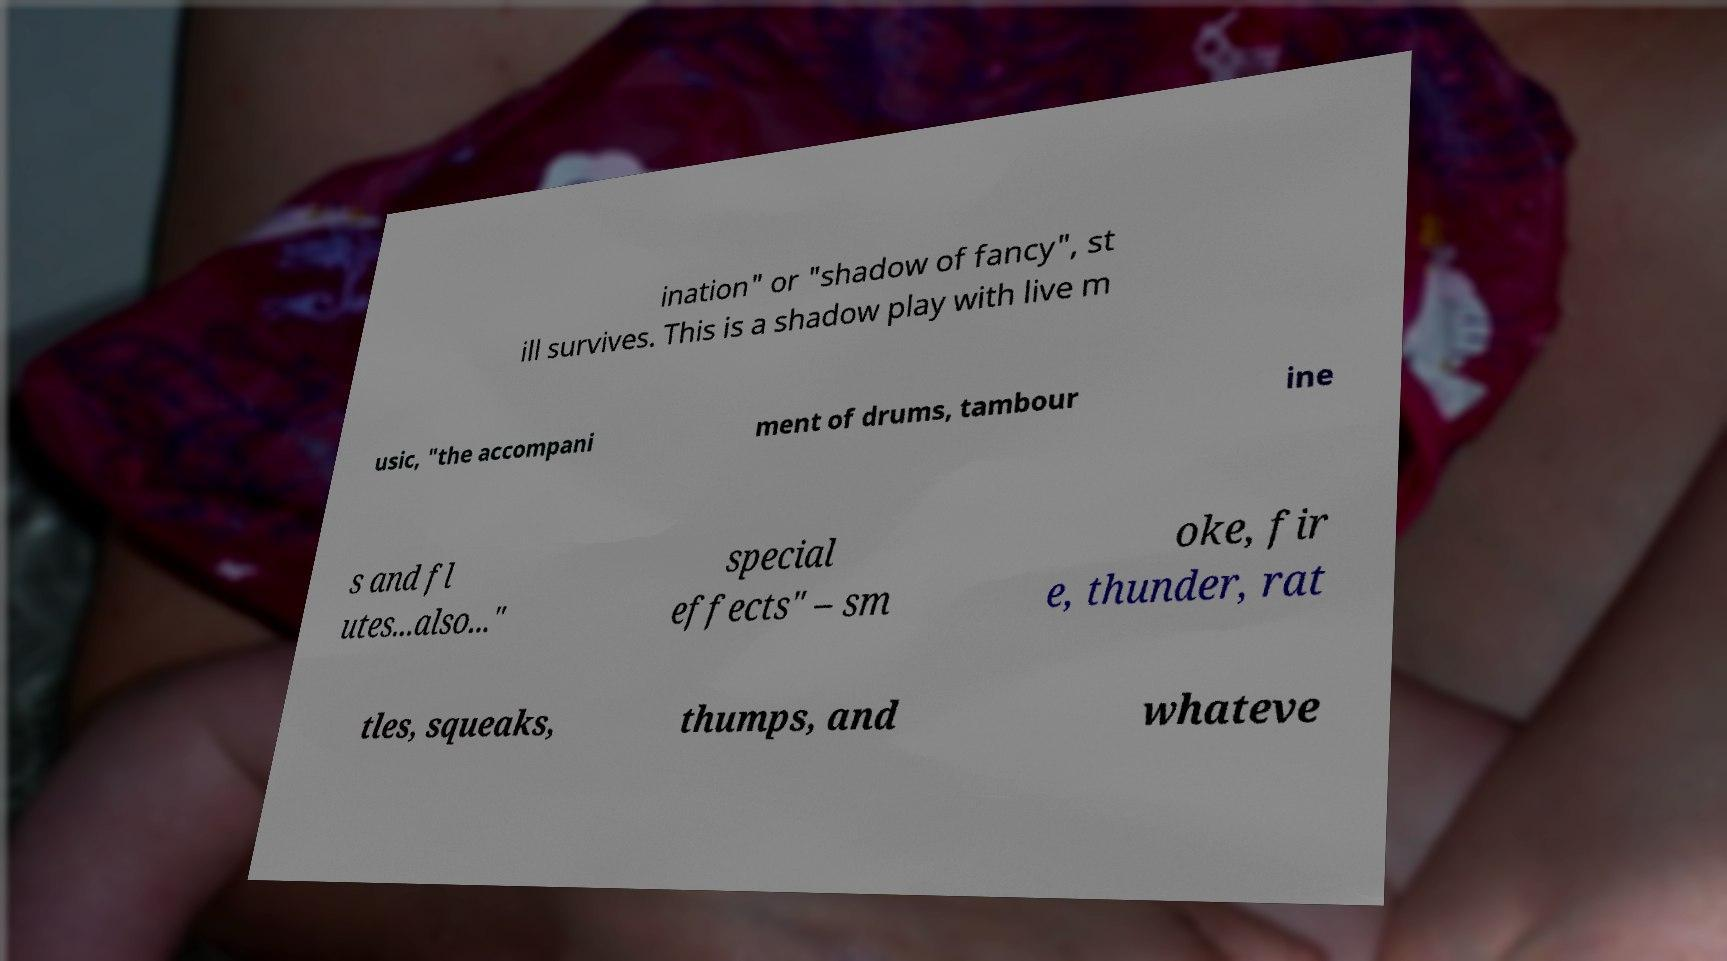Please identify and transcribe the text found in this image. ination" or "shadow of fancy", st ill survives. This is a shadow play with live m usic, "the accompani ment of drums, tambour ine s and fl utes...also..." special effects" – sm oke, fir e, thunder, rat tles, squeaks, thumps, and whateve 